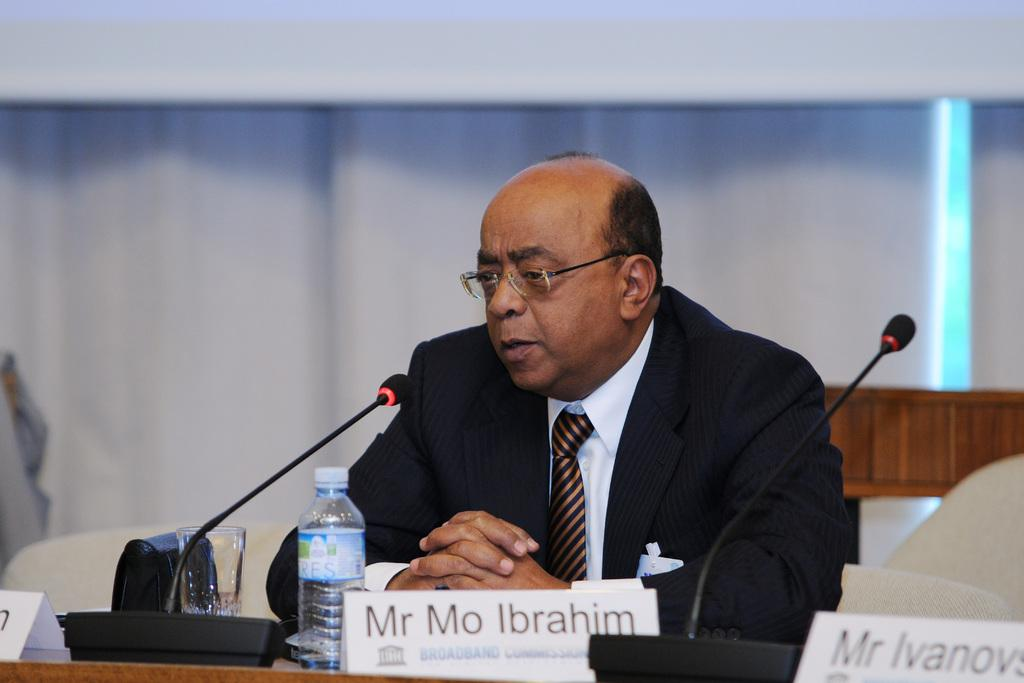Who is present in the image? There is a man in the image. What is the man doing in the image? The man is sitting on a chair. Where is the chair located in the image? The chair is at a table. What is the man doing while sitting on the chair? The man is speaking. How many boys are visible in the image? There are no boys present in the image; it features a man sitting on a chair. What type of receipt can be seen on the table in the image? There is no receipt visible in the image; it only shows a man sitting on a chair at a table. 